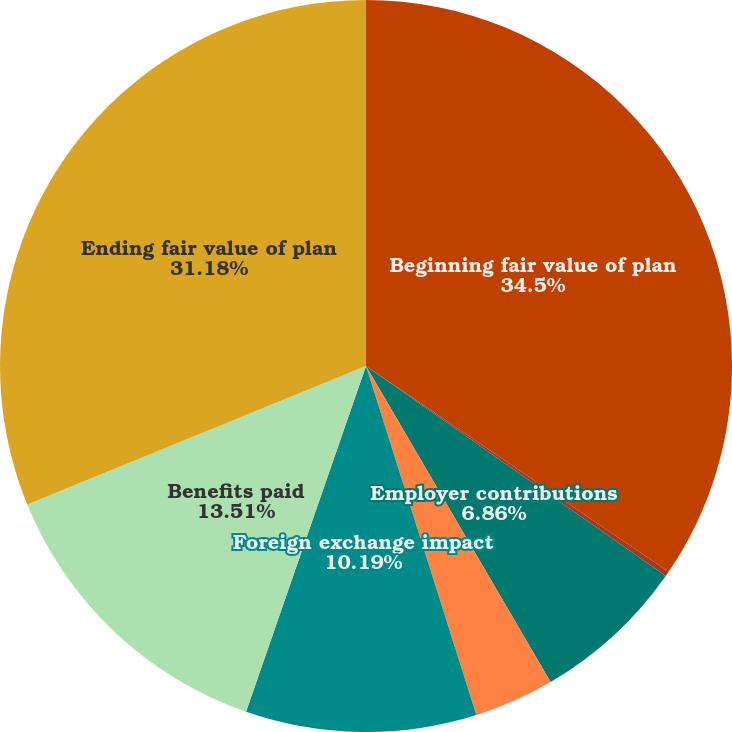<chart> <loc_0><loc_0><loc_500><loc_500><pie_chart><fcel>Beginning fair value of plan<fcel>Actual return<fcel>Employer contributions<fcel>Employee contributions<fcel>Foreign exchange impact<fcel>Benefits paid<fcel>Ending fair value of plan<nl><fcel>34.51%<fcel>0.22%<fcel>6.86%<fcel>3.54%<fcel>10.19%<fcel>13.51%<fcel>31.18%<nl></chart> 